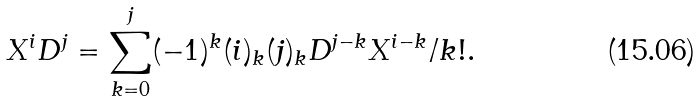Convert formula to latex. <formula><loc_0><loc_0><loc_500><loc_500>X ^ { i } D ^ { j } = \sum _ { k = 0 } ^ { j } ( - 1 ) ^ { k } ( i ) _ { k } ( j ) _ { k } D ^ { j - k } X ^ { i - k } / k ! .</formula> 